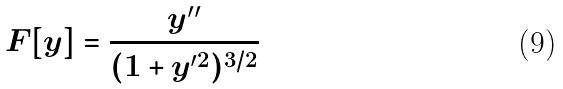Convert formula to latex. <formula><loc_0><loc_0><loc_500><loc_500>F [ y ] = \frac { y ^ { \prime \prime } } { ( 1 + y ^ { \prime 2 } ) ^ { 3 / 2 } }</formula> 